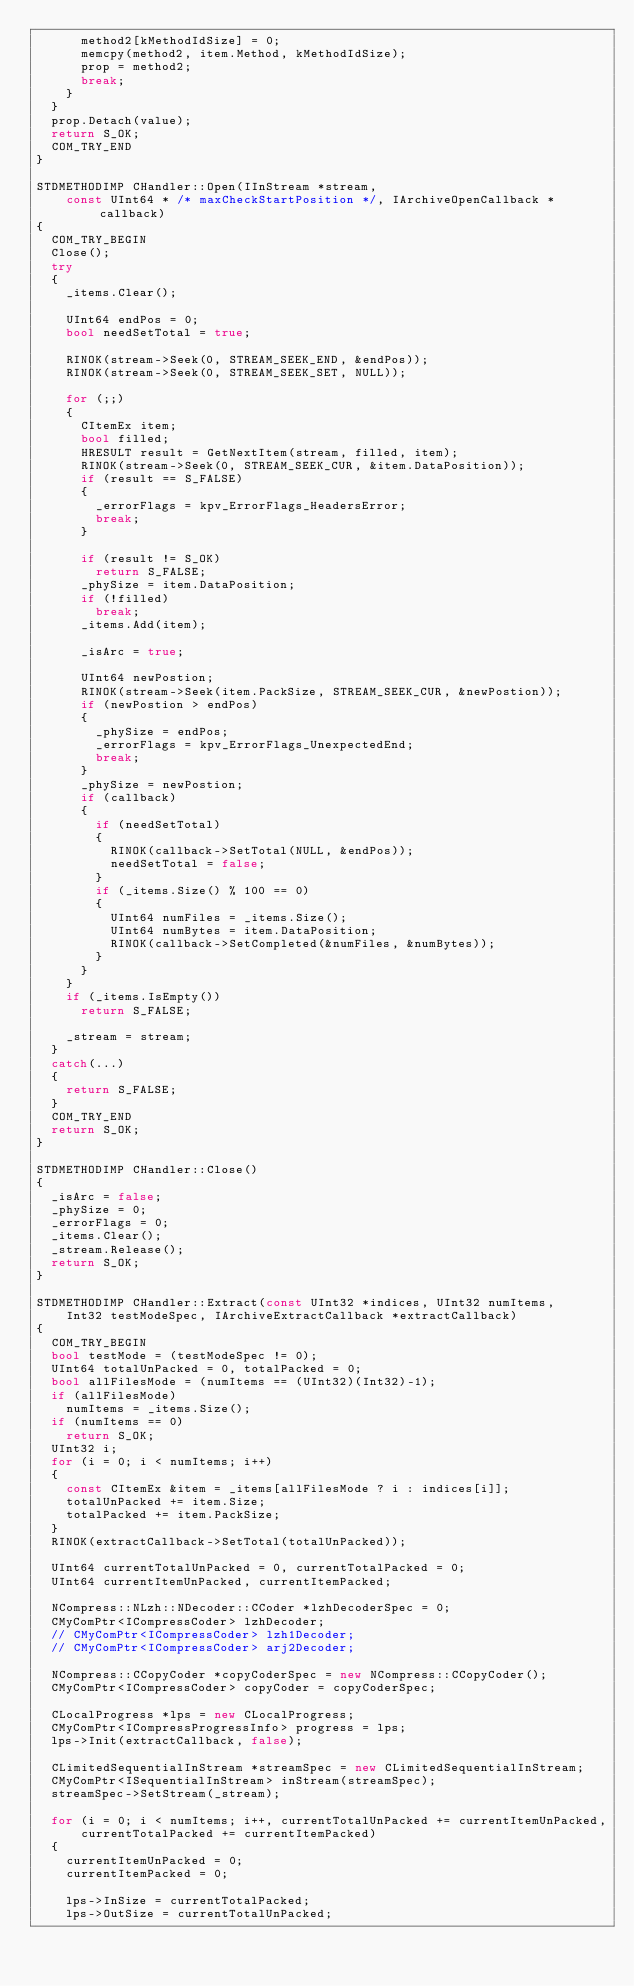<code> <loc_0><loc_0><loc_500><loc_500><_C++_>      method2[kMethodIdSize] = 0;
      memcpy(method2, item.Method, kMethodIdSize);
      prop = method2;
      break;
    }
  }
  prop.Detach(value);
  return S_OK;
  COM_TRY_END
}

STDMETHODIMP CHandler::Open(IInStream *stream,
    const UInt64 * /* maxCheckStartPosition */, IArchiveOpenCallback *callback)
{
  COM_TRY_BEGIN
  Close();
  try
  {
    _items.Clear();

    UInt64 endPos = 0;
    bool needSetTotal = true;

    RINOK(stream->Seek(0, STREAM_SEEK_END, &endPos));
    RINOK(stream->Seek(0, STREAM_SEEK_SET, NULL));

    for (;;)
    {
      CItemEx item;
      bool filled;
      HRESULT result = GetNextItem(stream, filled, item);
      RINOK(stream->Seek(0, STREAM_SEEK_CUR, &item.DataPosition));
      if (result == S_FALSE)
      {
        _errorFlags = kpv_ErrorFlags_HeadersError;
        break;
      }

      if (result != S_OK)
        return S_FALSE;
      _phySize = item.DataPosition;
      if (!filled)
        break;
      _items.Add(item);

      _isArc = true;

      UInt64 newPostion;
      RINOK(stream->Seek(item.PackSize, STREAM_SEEK_CUR, &newPostion));
      if (newPostion > endPos)
      {
        _phySize = endPos;
        _errorFlags = kpv_ErrorFlags_UnexpectedEnd;
        break;
      }
      _phySize = newPostion;
      if (callback)
      {
        if (needSetTotal)
        {
          RINOK(callback->SetTotal(NULL, &endPos));
          needSetTotal = false;
        }
        if (_items.Size() % 100 == 0)
        {
          UInt64 numFiles = _items.Size();
          UInt64 numBytes = item.DataPosition;
          RINOK(callback->SetCompleted(&numFiles, &numBytes));
        }
      }
    }
    if (_items.IsEmpty())
      return S_FALSE;

    _stream = stream;
  }
  catch(...)
  {
    return S_FALSE;
  }
  COM_TRY_END
  return S_OK;
}

STDMETHODIMP CHandler::Close()
{
  _isArc = false;
  _phySize = 0;
  _errorFlags = 0;
  _items.Clear();
  _stream.Release();
  return S_OK;
}

STDMETHODIMP CHandler::Extract(const UInt32 *indices, UInt32 numItems,
    Int32 testModeSpec, IArchiveExtractCallback *extractCallback)
{
  COM_TRY_BEGIN
  bool testMode = (testModeSpec != 0);
  UInt64 totalUnPacked = 0, totalPacked = 0;
  bool allFilesMode = (numItems == (UInt32)(Int32)-1);
  if (allFilesMode)
    numItems = _items.Size();
  if (numItems == 0)
    return S_OK;
  UInt32 i;
  for (i = 0; i < numItems; i++)
  {
    const CItemEx &item = _items[allFilesMode ? i : indices[i]];
    totalUnPacked += item.Size;
    totalPacked += item.PackSize;
  }
  RINOK(extractCallback->SetTotal(totalUnPacked));

  UInt64 currentTotalUnPacked = 0, currentTotalPacked = 0;
  UInt64 currentItemUnPacked, currentItemPacked;
  
  NCompress::NLzh::NDecoder::CCoder *lzhDecoderSpec = 0;
  CMyComPtr<ICompressCoder> lzhDecoder;
  // CMyComPtr<ICompressCoder> lzh1Decoder;
  // CMyComPtr<ICompressCoder> arj2Decoder;

  NCompress::CCopyCoder *copyCoderSpec = new NCompress::CCopyCoder();
  CMyComPtr<ICompressCoder> copyCoder = copyCoderSpec;

  CLocalProgress *lps = new CLocalProgress;
  CMyComPtr<ICompressProgressInfo> progress = lps;
  lps->Init(extractCallback, false);

  CLimitedSequentialInStream *streamSpec = new CLimitedSequentialInStream;
  CMyComPtr<ISequentialInStream> inStream(streamSpec);
  streamSpec->SetStream(_stream);

  for (i = 0; i < numItems; i++, currentTotalUnPacked += currentItemUnPacked,
      currentTotalPacked += currentItemPacked)
  {
    currentItemUnPacked = 0;
    currentItemPacked = 0;

    lps->InSize = currentTotalPacked;
    lps->OutSize = currentTotalUnPacked;</code> 